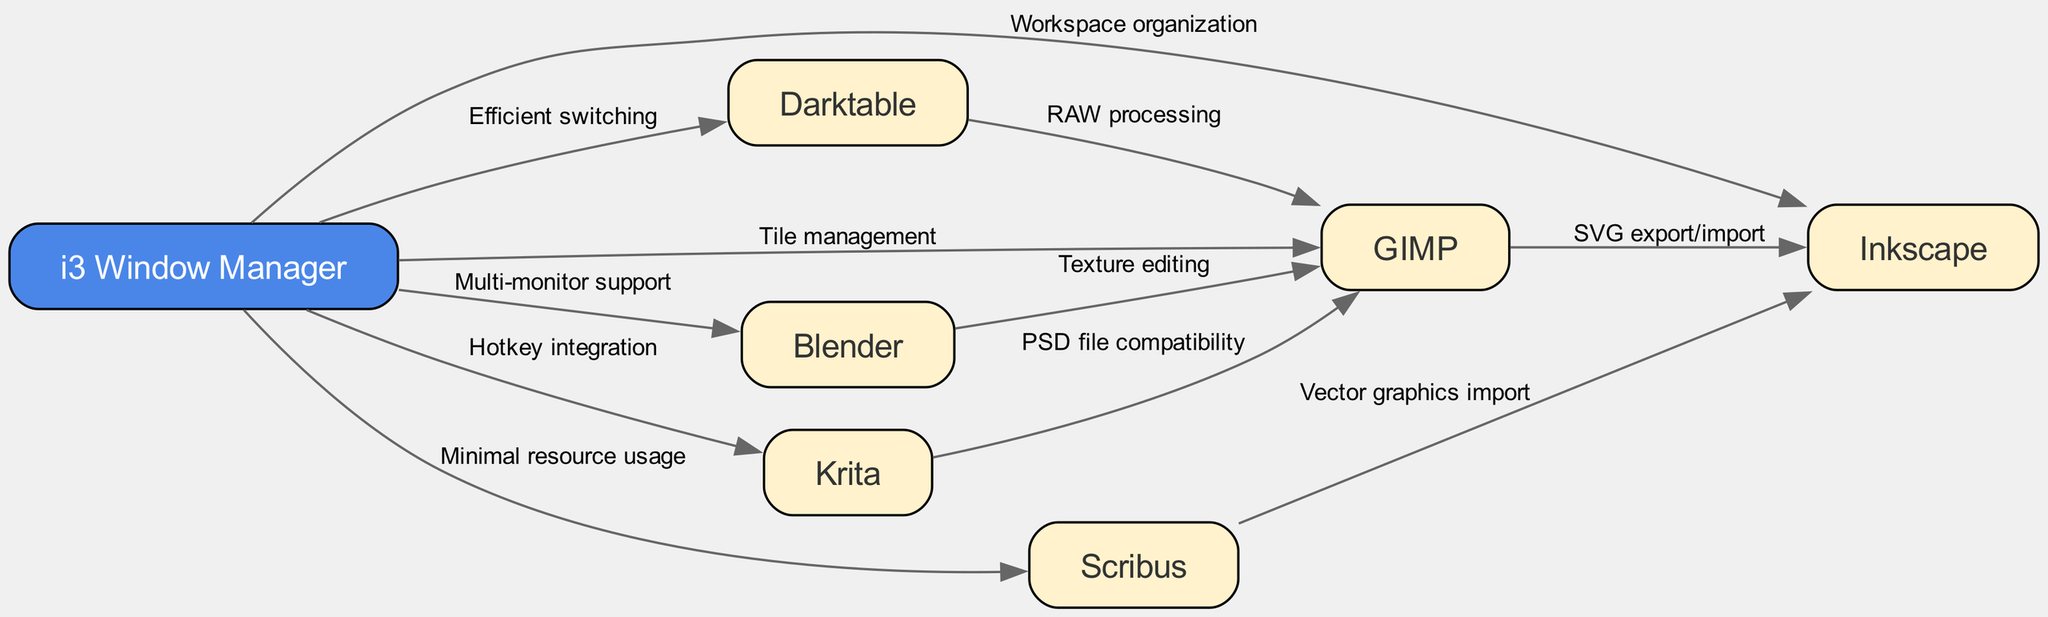What is the total number of nodes in the diagram? The diagram contains nodes for the i3 Window Manager and six open-source design applications: GIMP, Inkscape, Krita, Darktable, Blender, and Scribus. Counting these nodes results in a total of seven nodes.
Answer: 7 Which application is connected to GIMP for PSD file compatibility? The edge from Krita to GIMP indicates that Krita offers PSD file compatibility with GIMP, making Krita the application connected to GIMP for this purpose.
Answer: Krita What type of relationship exists between i3 Window Manager and Blender? The edge labeled "Multi-monitor support" defines the relationship between the i3 Window Manager and Blender, indicating that the i3 Window Manager facilitates support for multiple monitors when using Blender.
Answer: Multi-monitor support How many applications are interconnected with i3 Window Manager? The edges indicate that i3 Window Manager is connected to GIMP, Inkscape, Krita, Darktable, Blender, and Scribus. Counting these connections shows that there are six applications interconnected with the i3 Window Manager.
Answer: 6 Which application imports vector graphics from Scribus? The edge labeled "Vector graphics import" shows that Inkscape imports vector graphics from Scribus, highlighting the relationship between these two applications.
Answer: Inkscape What feature allows efficient switching to Darktable from i3 Window Manager? The diagram describes "Efficient switching" as the edge connecting i3 Window Manager to Darktable, indicating that this feature allows for smoothly transitioning from the i3 Window Manager to Darktable.
Answer: Efficient switching Which two applications share a connection for RAW processing? The edge from Darktable to GIMP depicts RAW processing, meaning GIMP receives RAW files from Darktable for processing. This establishes the connection primarily focused on RAW file handling.
Answer: Darktable How does GIMP interact with Inkscape in the diagram? The diagram reveals that GIMP and Inkscape are connected via an edge labeled "SVG export/import," illustrating the interaction between these two applications for handling SVG files.
Answer: SVG export/import What is the primary purpose of using i3 Window Manager in conjunction with these applications? The diagram outlines various edges describing features like "Tile management," "Workspace organization," and "Hotkey integration," emphasizing that the i3 Window Manager enhances the overall workflow's efficiency when using these design applications.
Answer: Efficiency 